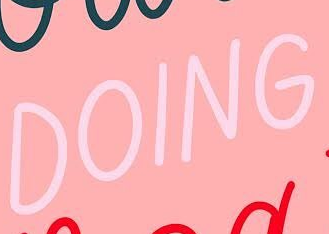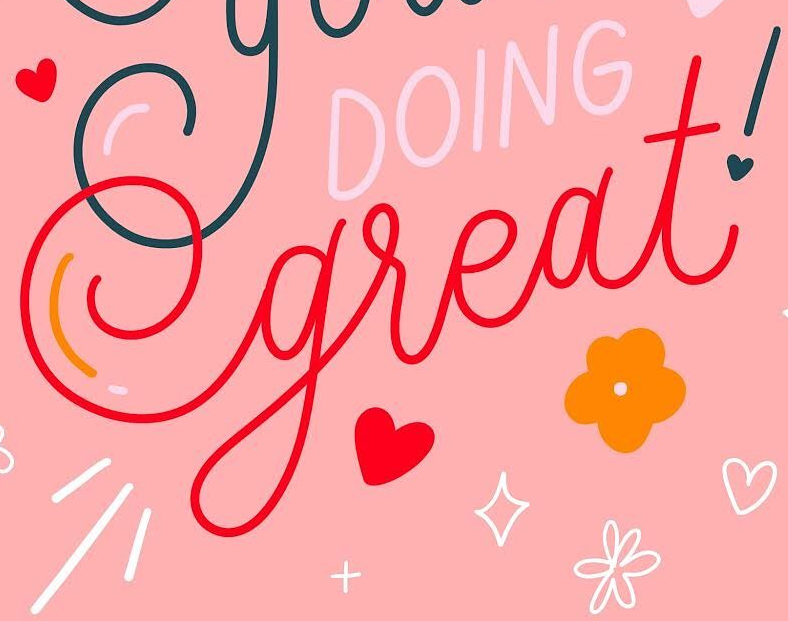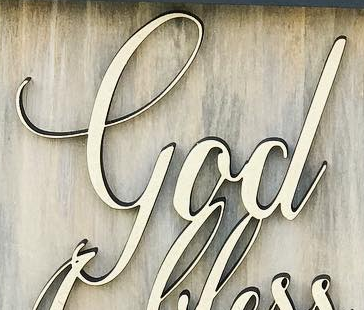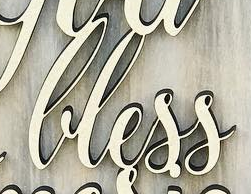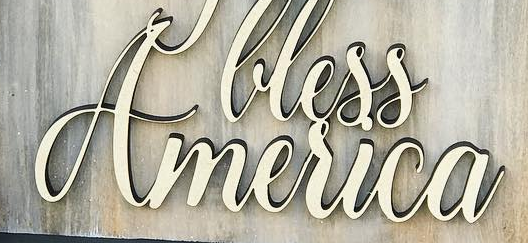Identify the words shown in these images in order, separated by a semicolon. DOING; great!; God; lless; America 